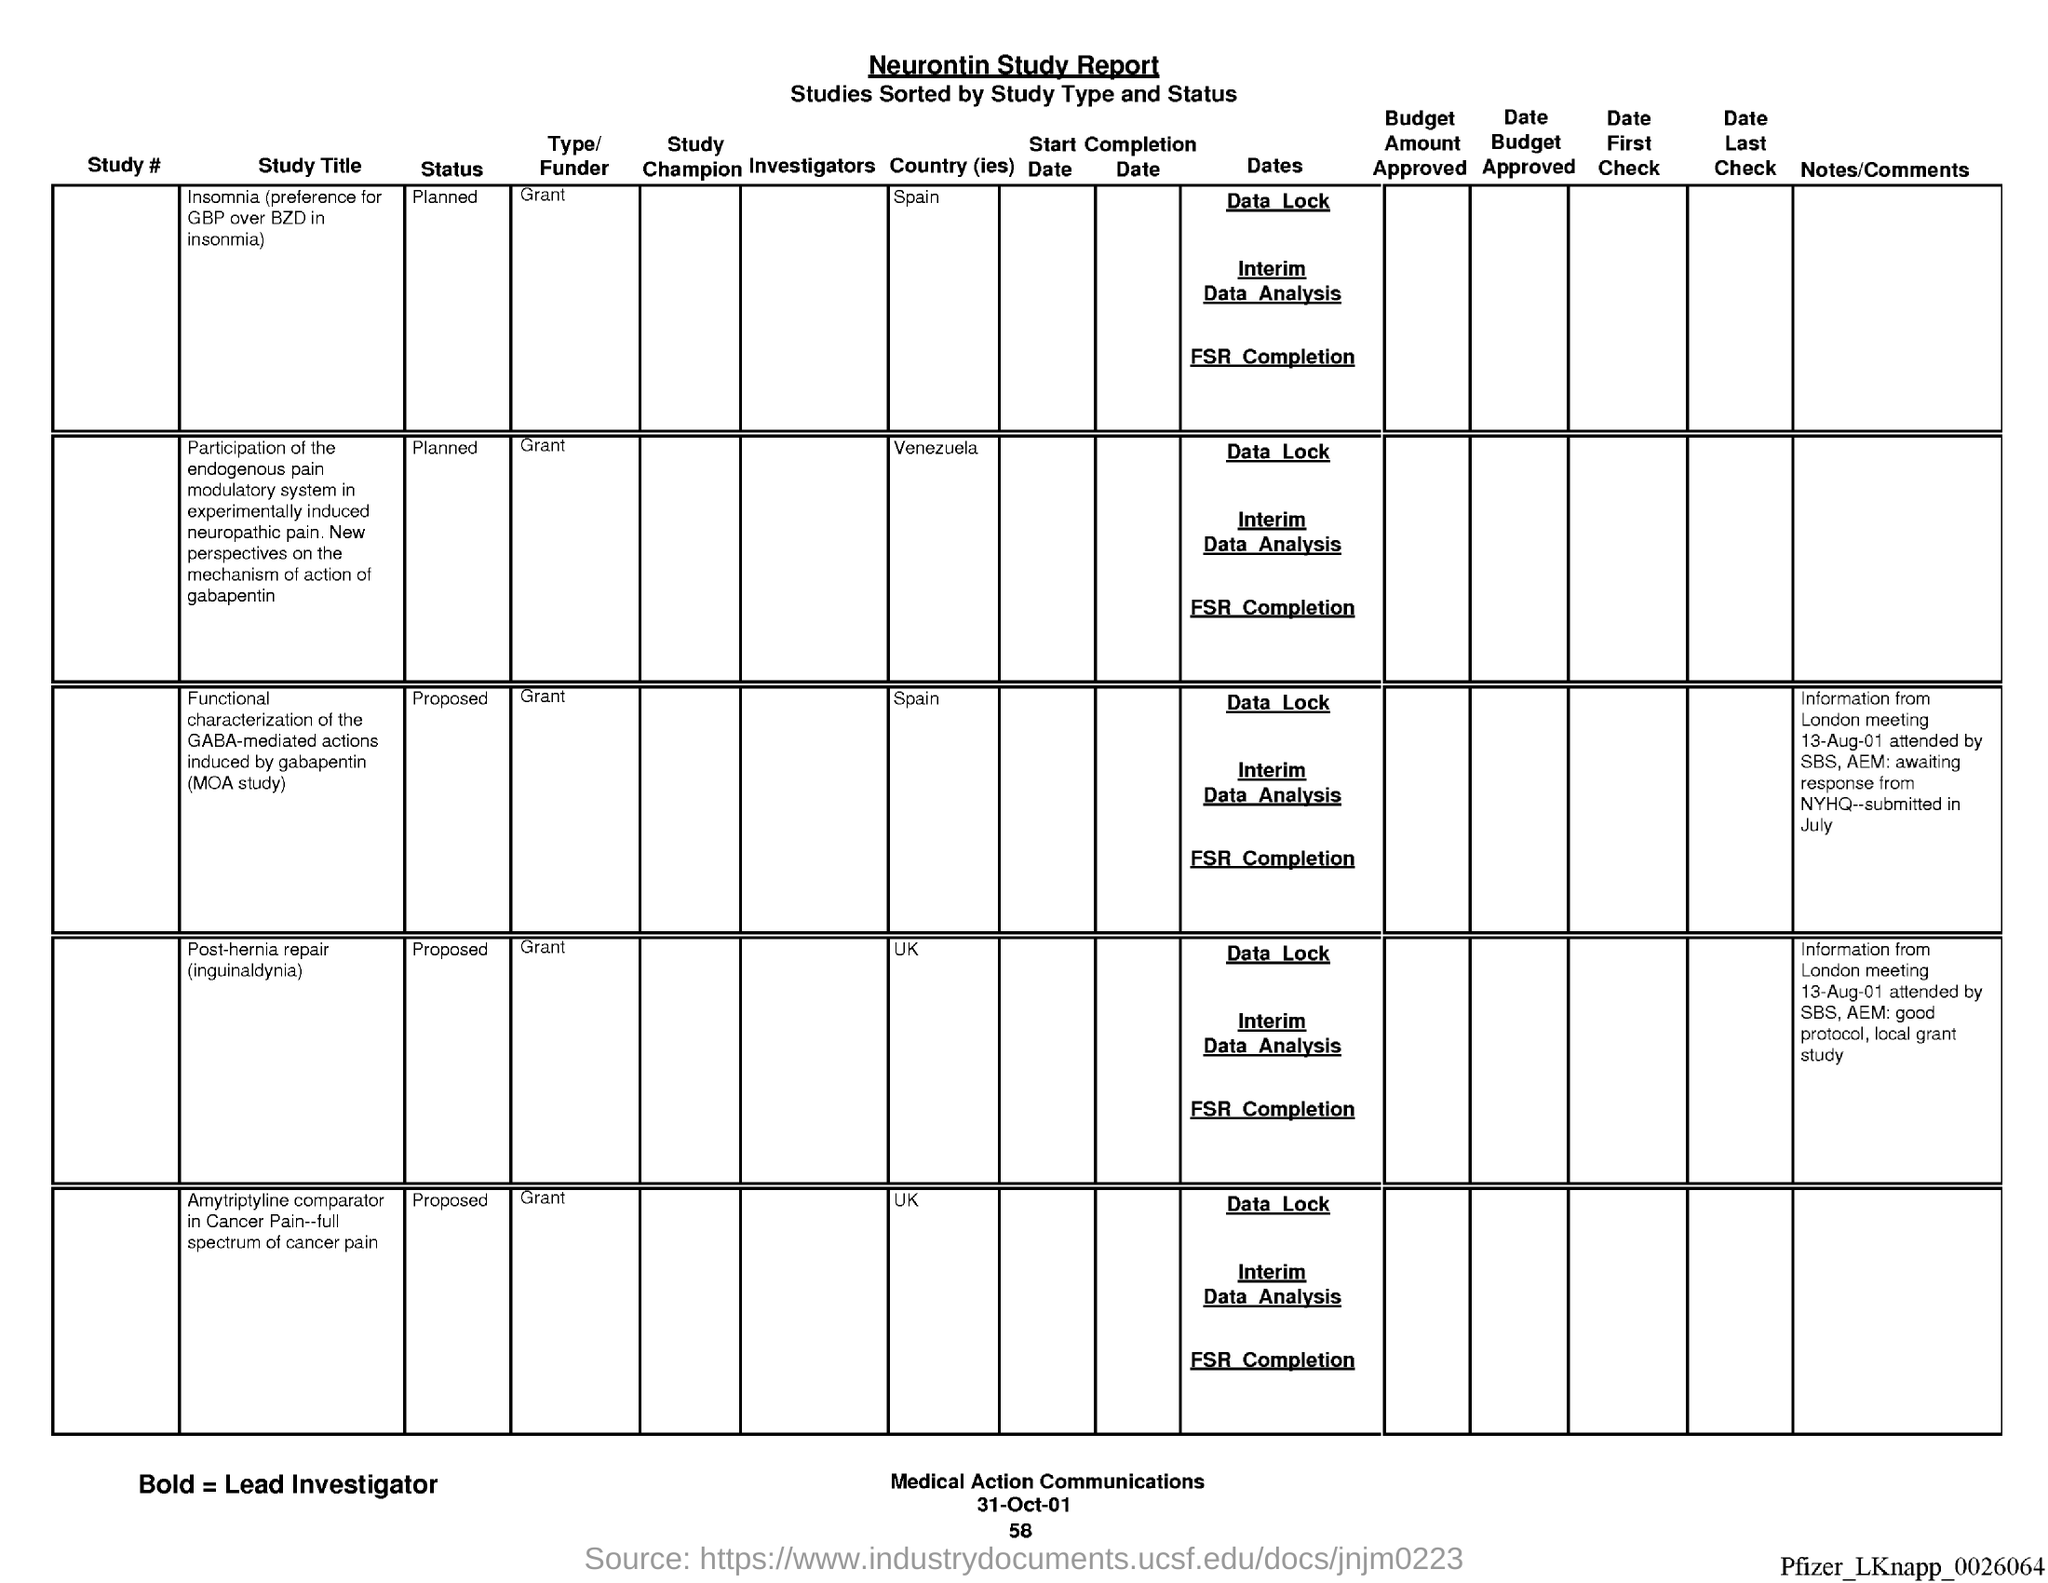Point out several critical features in this image. I would like to declare that the date is 31 October 2001. This document is about a study report on Neurontin. 